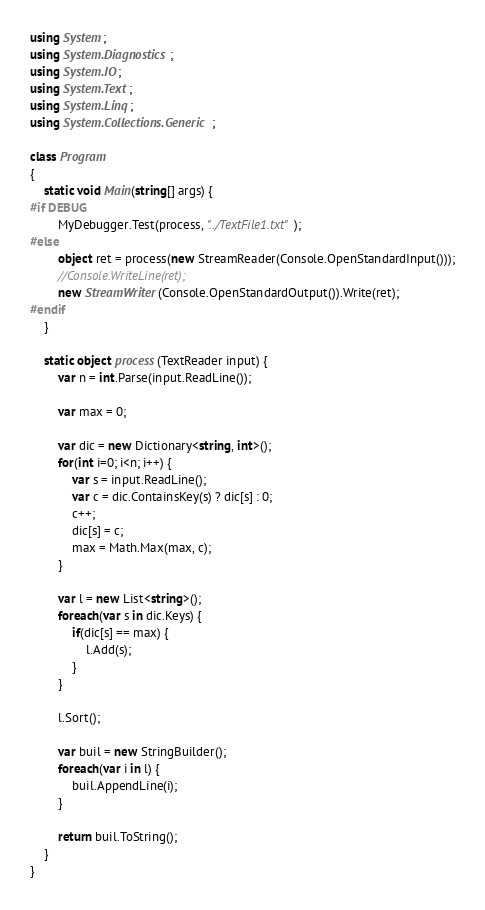<code> <loc_0><loc_0><loc_500><loc_500><_C#_>using System;
using System.Diagnostics;
using System.IO;
using System.Text;
using System.Linq;
using System.Collections.Generic;

class Program
{
    static void Main(string[] args) {
#if DEBUG
        MyDebugger.Test(process, "../TextFile1.txt");
#else
        object ret = process(new StreamReader(Console.OpenStandardInput()));
        //Console.WriteLine(ret);
        new StreamWriter(Console.OpenStandardOutput()).Write(ret);
#endif
    }

    static object process(TextReader input) {
        var n = int.Parse(input.ReadLine());

        var max = 0;

        var dic = new Dictionary<string, int>();
        for(int i=0; i<n; i++) {
            var s = input.ReadLine();
            var c = dic.ContainsKey(s) ? dic[s] : 0;
            c++;
            dic[s] = c;
            max = Math.Max(max, c);
        }

        var l = new List<string>();
        foreach(var s in dic.Keys) {
            if(dic[s] == max) {
                l.Add(s);
            }
        }

        l.Sort();

        var buil = new StringBuilder();
        foreach(var i in l) {
            buil.AppendLine(i);
        }

        return buil.ToString();
    }
}
</code> 